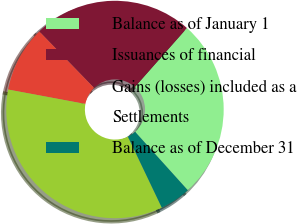<chart> <loc_0><loc_0><loc_500><loc_500><pie_chart><fcel>Balance as of January 1<fcel>Issuances of financial<fcel>Gains (losses) included as a<fcel>Settlements<fcel>Balance as of December 31<nl><fcel>26.81%<fcel>23.77%<fcel>9.8%<fcel>35.03%<fcel>4.59%<nl></chart> 